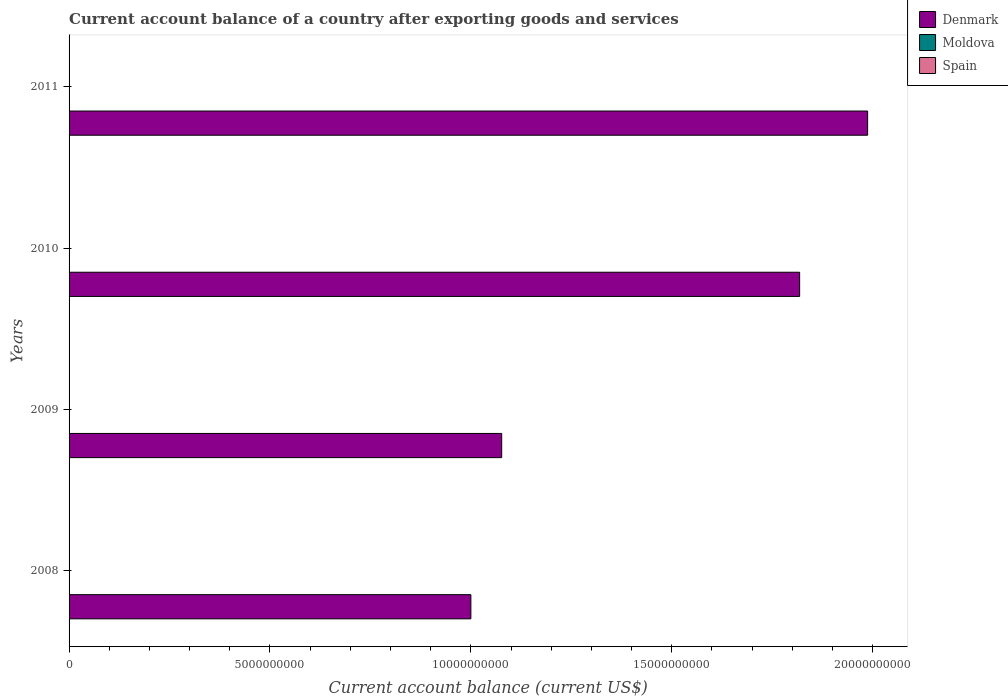Are the number of bars on each tick of the Y-axis equal?
Keep it short and to the point. Yes. What is the label of the 3rd group of bars from the top?
Provide a short and direct response. 2009. What is the account balance in Denmark in 2008?
Give a very brief answer. 1.00e+1. Across all years, what is the maximum account balance in Denmark?
Provide a succinct answer. 1.99e+1. Across all years, what is the minimum account balance in Denmark?
Your answer should be very brief. 1.00e+1. What is the difference between the account balance in Denmark in 2009 and that in 2010?
Your response must be concise. -7.42e+09. What is the difference between the account balance in Denmark in 2010 and the account balance in Moldova in 2011?
Give a very brief answer. 1.82e+1. In how many years, is the account balance in Moldova greater than 1000000000 US$?
Your answer should be very brief. 0. What is the ratio of the account balance in Denmark in 2008 to that in 2011?
Make the answer very short. 0.5. Is the account balance in Denmark in 2009 less than that in 2011?
Make the answer very short. Yes. What is the difference between the highest and the second highest account balance in Denmark?
Provide a short and direct response. 1.69e+09. What is the difference between the highest and the lowest account balance in Denmark?
Your answer should be compact. 9.87e+09. In how many years, is the account balance in Spain greater than the average account balance in Spain taken over all years?
Your answer should be very brief. 0. Is the sum of the account balance in Denmark in 2010 and 2011 greater than the maximum account balance in Spain across all years?
Ensure brevity in your answer.  Yes. Are all the bars in the graph horizontal?
Provide a short and direct response. Yes. How many years are there in the graph?
Provide a short and direct response. 4. Are the values on the major ticks of X-axis written in scientific E-notation?
Provide a short and direct response. No. Does the graph contain grids?
Keep it short and to the point. No. Where does the legend appear in the graph?
Make the answer very short. Top right. How many legend labels are there?
Offer a very short reply. 3. How are the legend labels stacked?
Provide a short and direct response. Vertical. What is the title of the graph?
Your answer should be very brief. Current account balance of a country after exporting goods and services. What is the label or title of the X-axis?
Offer a terse response. Current account balance (current US$). What is the Current account balance (current US$) of Denmark in 2008?
Make the answer very short. 1.00e+1. What is the Current account balance (current US$) in Moldova in 2008?
Keep it short and to the point. 0. What is the Current account balance (current US$) in Denmark in 2009?
Offer a terse response. 1.08e+1. What is the Current account balance (current US$) in Moldova in 2009?
Make the answer very short. 0. What is the Current account balance (current US$) of Spain in 2009?
Make the answer very short. 0. What is the Current account balance (current US$) of Denmark in 2010?
Offer a terse response. 1.82e+1. What is the Current account balance (current US$) in Moldova in 2010?
Give a very brief answer. 0. What is the Current account balance (current US$) in Spain in 2010?
Your answer should be compact. 0. What is the Current account balance (current US$) in Denmark in 2011?
Offer a terse response. 1.99e+1. What is the Current account balance (current US$) of Moldova in 2011?
Ensure brevity in your answer.  0. What is the Current account balance (current US$) of Spain in 2011?
Offer a very short reply. 0. Across all years, what is the maximum Current account balance (current US$) in Denmark?
Your response must be concise. 1.99e+1. Across all years, what is the minimum Current account balance (current US$) in Denmark?
Keep it short and to the point. 1.00e+1. What is the total Current account balance (current US$) in Denmark in the graph?
Your answer should be compact. 5.88e+1. What is the total Current account balance (current US$) of Spain in the graph?
Give a very brief answer. 0. What is the difference between the Current account balance (current US$) in Denmark in 2008 and that in 2009?
Offer a very short reply. -7.67e+08. What is the difference between the Current account balance (current US$) in Denmark in 2008 and that in 2010?
Give a very brief answer. -8.18e+09. What is the difference between the Current account balance (current US$) in Denmark in 2008 and that in 2011?
Make the answer very short. -9.87e+09. What is the difference between the Current account balance (current US$) of Denmark in 2009 and that in 2010?
Ensure brevity in your answer.  -7.42e+09. What is the difference between the Current account balance (current US$) in Denmark in 2009 and that in 2011?
Provide a succinct answer. -9.11e+09. What is the difference between the Current account balance (current US$) of Denmark in 2010 and that in 2011?
Keep it short and to the point. -1.69e+09. What is the average Current account balance (current US$) of Denmark per year?
Ensure brevity in your answer.  1.47e+1. What is the average Current account balance (current US$) of Spain per year?
Ensure brevity in your answer.  0. What is the ratio of the Current account balance (current US$) of Denmark in 2008 to that in 2009?
Ensure brevity in your answer.  0.93. What is the ratio of the Current account balance (current US$) in Denmark in 2008 to that in 2010?
Your response must be concise. 0.55. What is the ratio of the Current account balance (current US$) of Denmark in 2008 to that in 2011?
Offer a very short reply. 0.5. What is the ratio of the Current account balance (current US$) of Denmark in 2009 to that in 2010?
Ensure brevity in your answer.  0.59. What is the ratio of the Current account balance (current US$) of Denmark in 2009 to that in 2011?
Provide a succinct answer. 0.54. What is the ratio of the Current account balance (current US$) in Denmark in 2010 to that in 2011?
Provide a succinct answer. 0.91. What is the difference between the highest and the second highest Current account balance (current US$) of Denmark?
Give a very brief answer. 1.69e+09. What is the difference between the highest and the lowest Current account balance (current US$) in Denmark?
Your answer should be compact. 9.87e+09. 